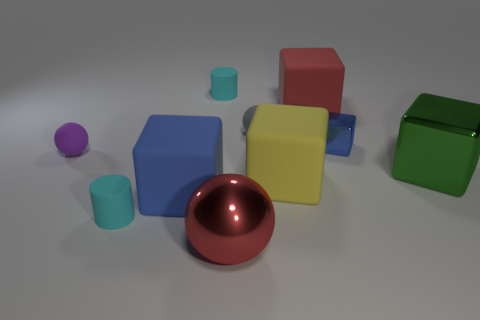Subtract all big red cubes. How many cubes are left? 4 Subtract 0 gray cylinders. How many objects are left? 10 Subtract all balls. How many objects are left? 7 Subtract 2 balls. How many balls are left? 1 Subtract all blue cylinders. Subtract all cyan cubes. How many cylinders are left? 2 Subtract all red cylinders. How many green blocks are left? 1 Subtract all small blue metallic things. Subtract all small gray matte things. How many objects are left? 8 Add 4 green shiny objects. How many green shiny objects are left? 5 Add 2 big red blocks. How many big red blocks exist? 3 Subtract all gray spheres. How many spheres are left? 2 